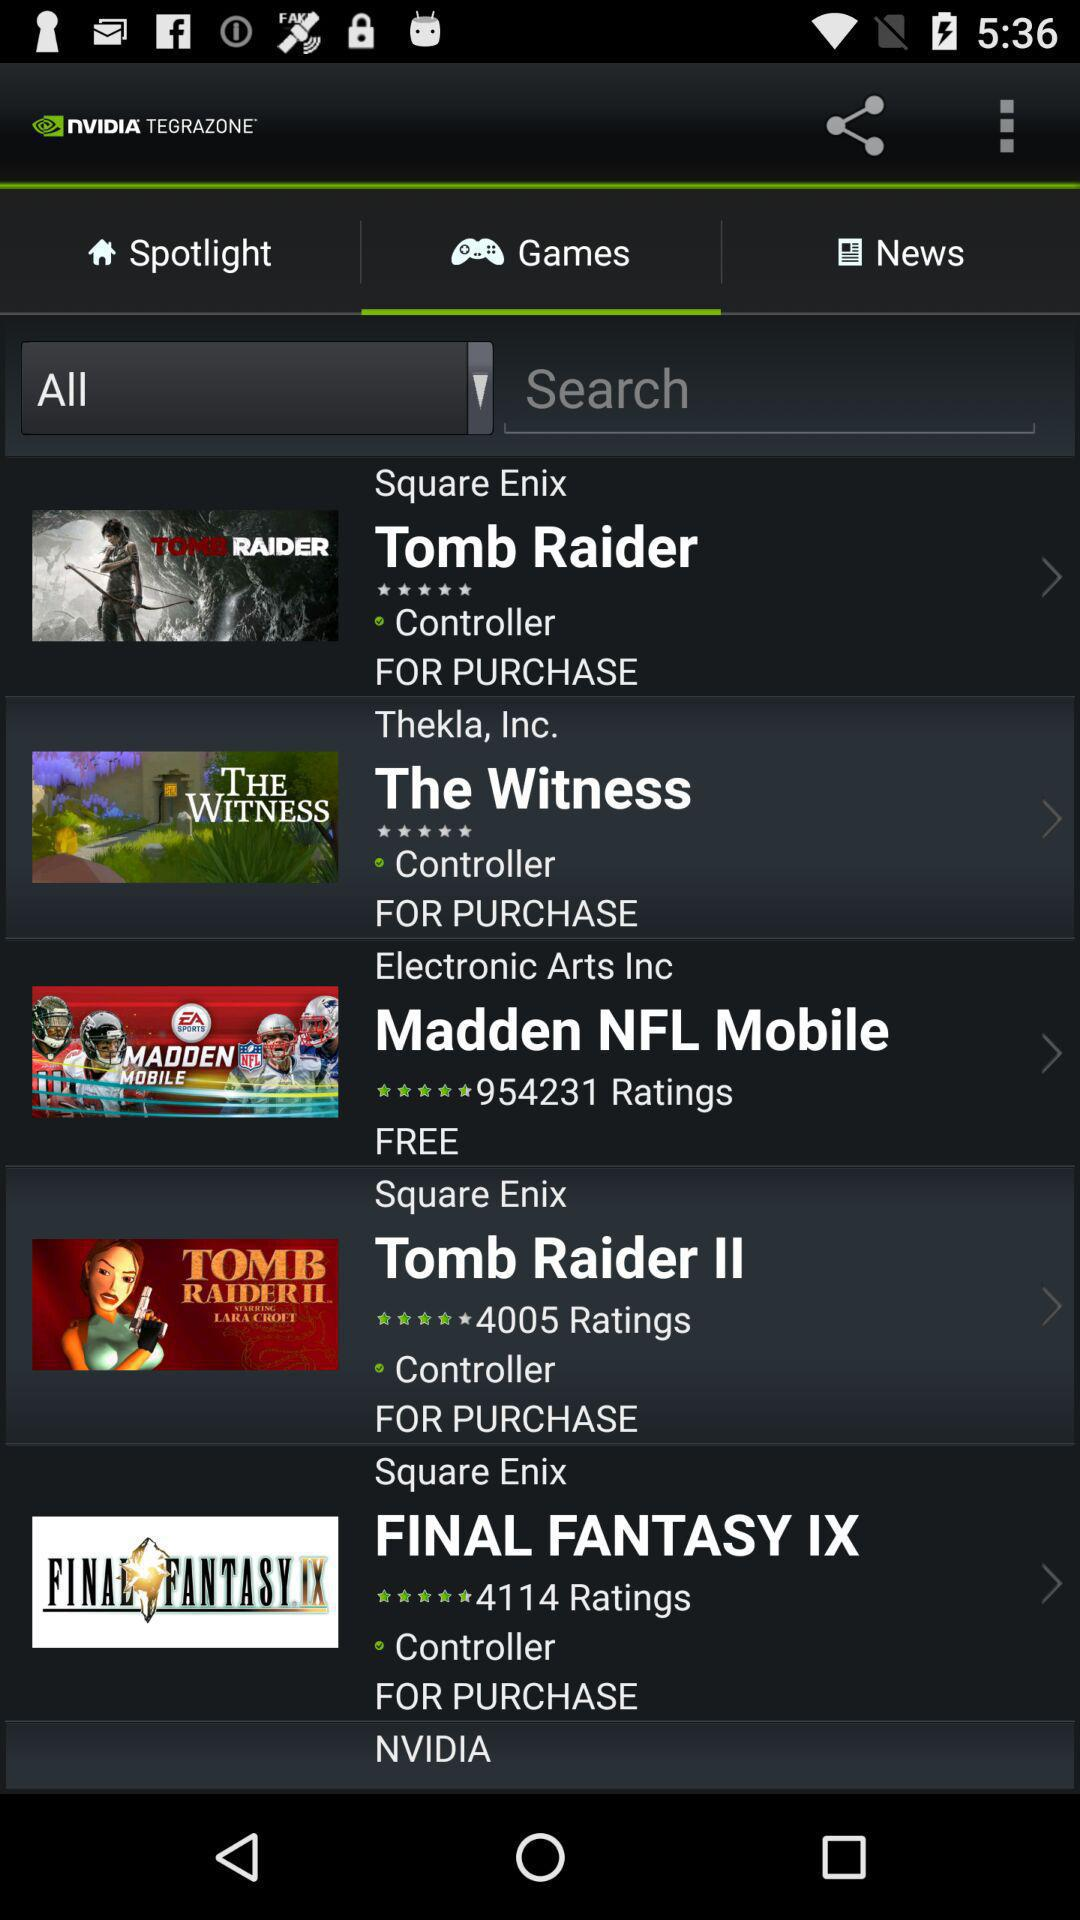What is the count of rating on tomb raider?
When the provided information is insufficient, respond with <no answer>. <no answer> 